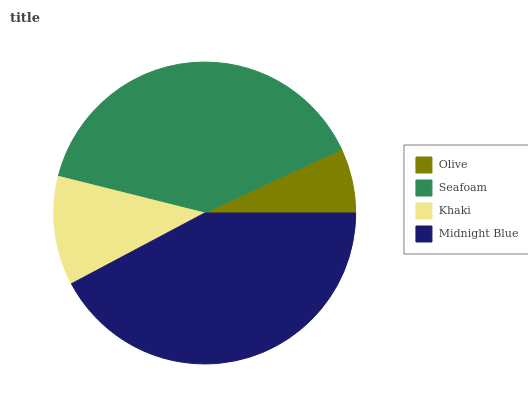Is Olive the minimum?
Answer yes or no. Yes. Is Midnight Blue the maximum?
Answer yes or no. Yes. Is Seafoam the minimum?
Answer yes or no. No. Is Seafoam the maximum?
Answer yes or no. No. Is Seafoam greater than Olive?
Answer yes or no. Yes. Is Olive less than Seafoam?
Answer yes or no. Yes. Is Olive greater than Seafoam?
Answer yes or no. No. Is Seafoam less than Olive?
Answer yes or no. No. Is Seafoam the high median?
Answer yes or no. Yes. Is Khaki the low median?
Answer yes or no. Yes. Is Khaki the high median?
Answer yes or no. No. Is Seafoam the low median?
Answer yes or no. No. 